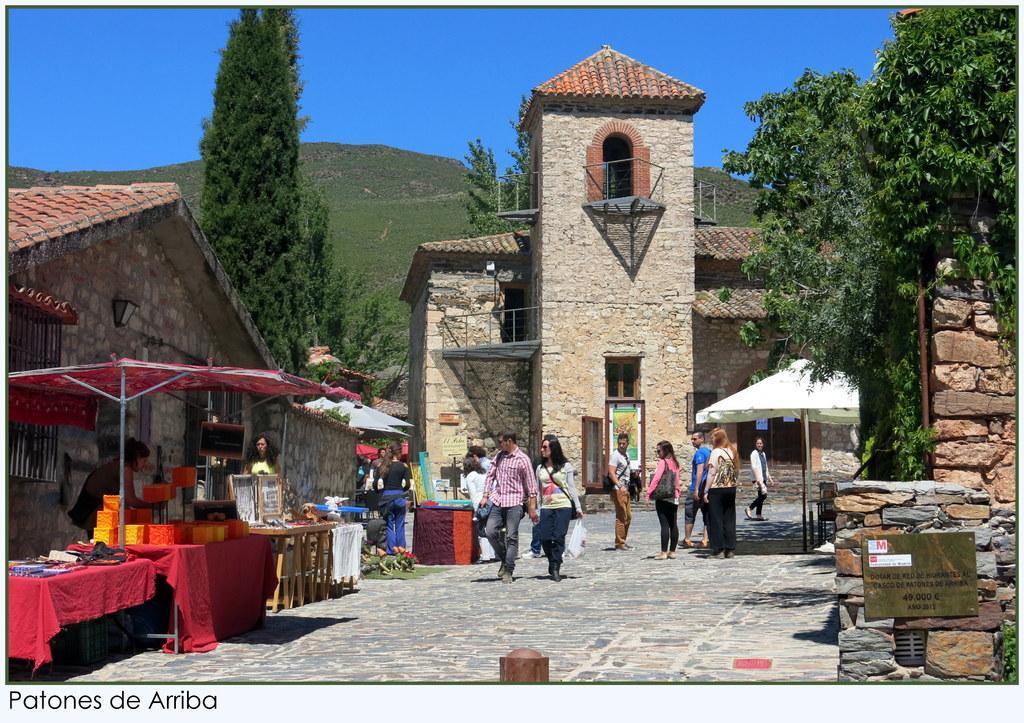In one or two sentences, can you explain what this image depicts? In this picture I can see few people walking in the middle. On the left it looks like a tent, in the background there are buildings and trees, there is the sky at the top. On the right side I can see a board, in the bottom left hand side there is the text. 